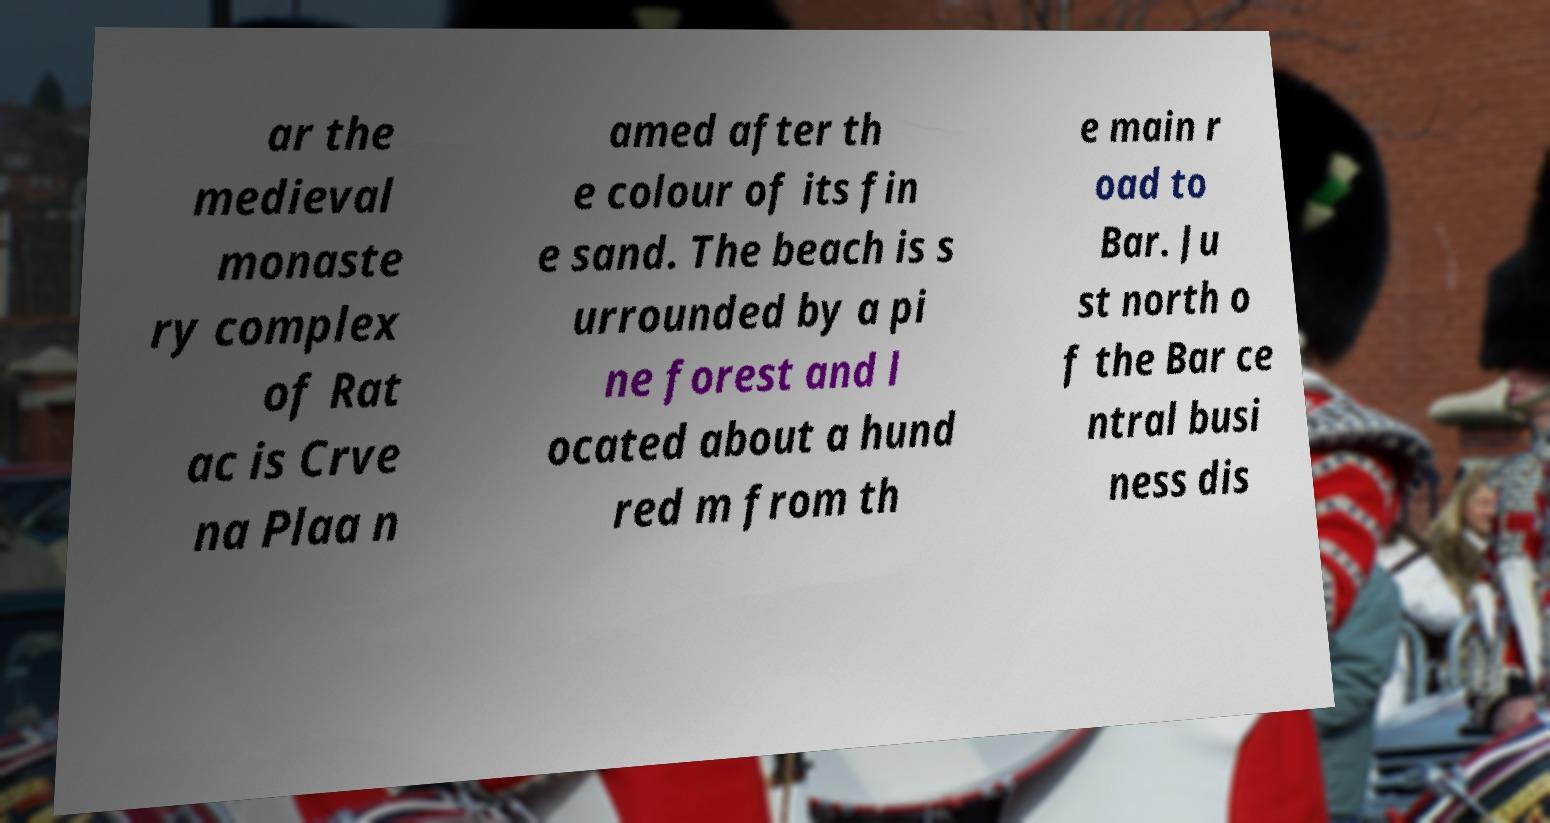Could you extract and type out the text from this image? ar the medieval monaste ry complex of Rat ac is Crve na Plaa n amed after th e colour of its fin e sand. The beach is s urrounded by a pi ne forest and l ocated about a hund red m from th e main r oad to Bar. Ju st north o f the Bar ce ntral busi ness dis 